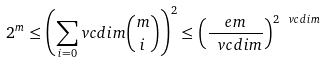Convert formula to latex. <formula><loc_0><loc_0><loc_500><loc_500>2 ^ { m } \leq \left ( \sum _ { i = 0 } ^ { \ } v c d i m \binom { m } { i } \right ) ^ { 2 } \leq \left ( \frac { e m } { \ v c d i m } \right ) ^ { 2 \ v c d i m }</formula> 